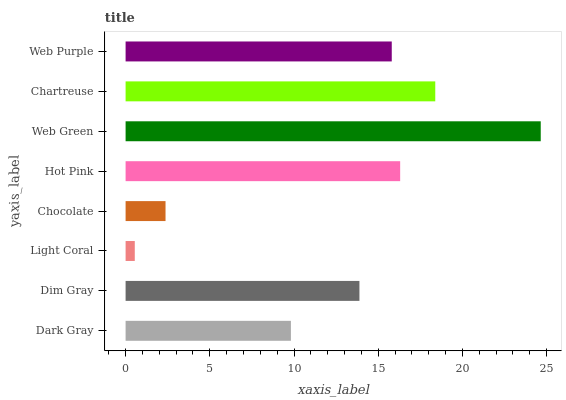Is Light Coral the minimum?
Answer yes or no. Yes. Is Web Green the maximum?
Answer yes or no. Yes. Is Dim Gray the minimum?
Answer yes or no. No. Is Dim Gray the maximum?
Answer yes or no. No. Is Dim Gray greater than Dark Gray?
Answer yes or no. Yes. Is Dark Gray less than Dim Gray?
Answer yes or no. Yes. Is Dark Gray greater than Dim Gray?
Answer yes or no. No. Is Dim Gray less than Dark Gray?
Answer yes or no. No. Is Web Purple the high median?
Answer yes or no. Yes. Is Dim Gray the low median?
Answer yes or no. Yes. Is Web Green the high median?
Answer yes or no. No. Is Dark Gray the low median?
Answer yes or no. No. 